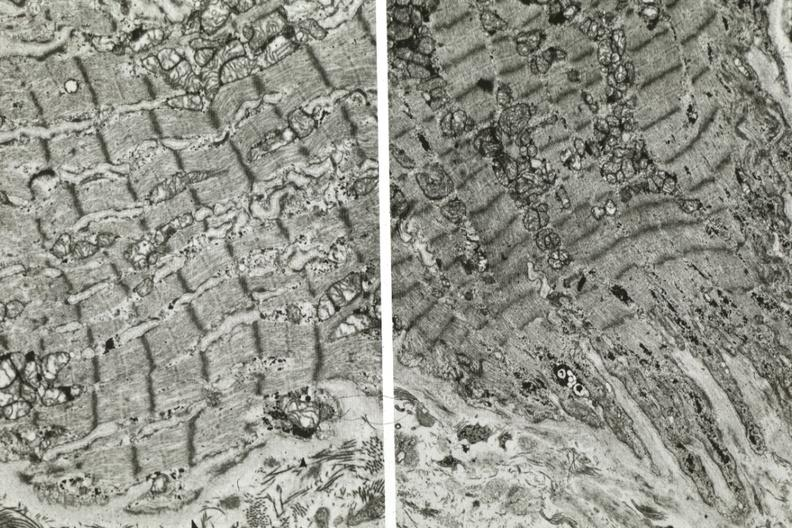what is present?
Answer the question using a single word or phrase. Atrophy 